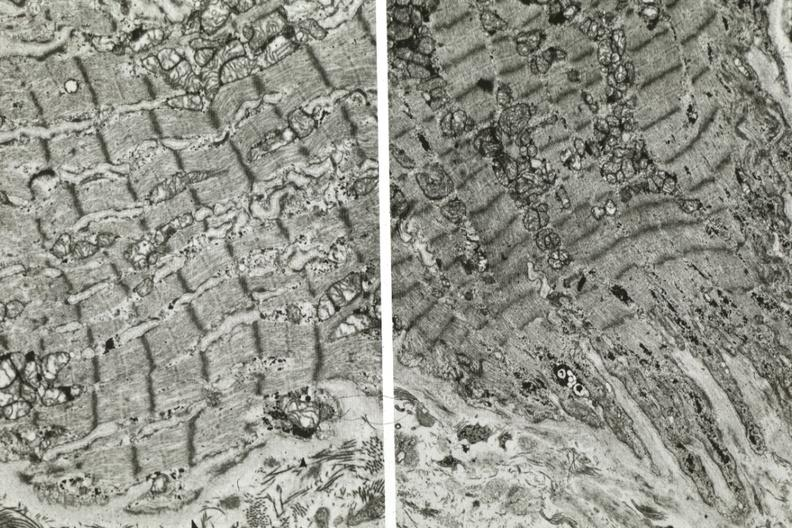what is present?
Answer the question using a single word or phrase. Atrophy 